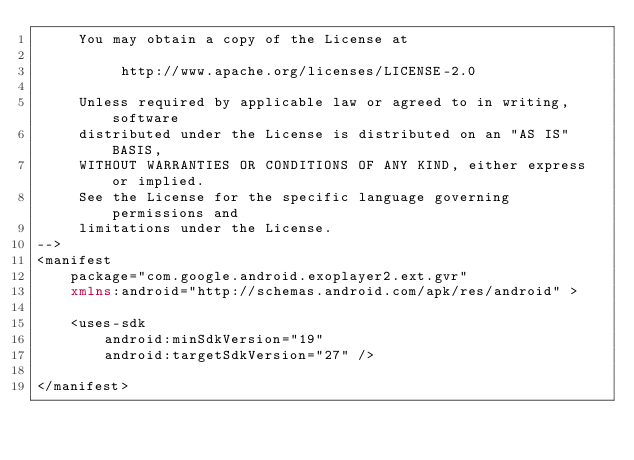Convert code to text. <code><loc_0><loc_0><loc_500><loc_500><_XML_>     You may obtain a copy of the License at

          http://www.apache.org/licenses/LICENSE-2.0

     Unless required by applicable law or agreed to in writing, software
     distributed under the License is distributed on an "AS IS" BASIS,
     WITHOUT WARRANTIES OR CONDITIONS OF ANY KIND, either express or implied.
     See the License for the specific language governing permissions and
     limitations under the License.
-->
<manifest
    package="com.google.android.exoplayer2.ext.gvr"
    xmlns:android="http://schemas.android.com/apk/res/android" >

    <uses-sdk
        android:minSdkVersion="19"
        android:targetSdkVersion="27" />

</manifest></code> 